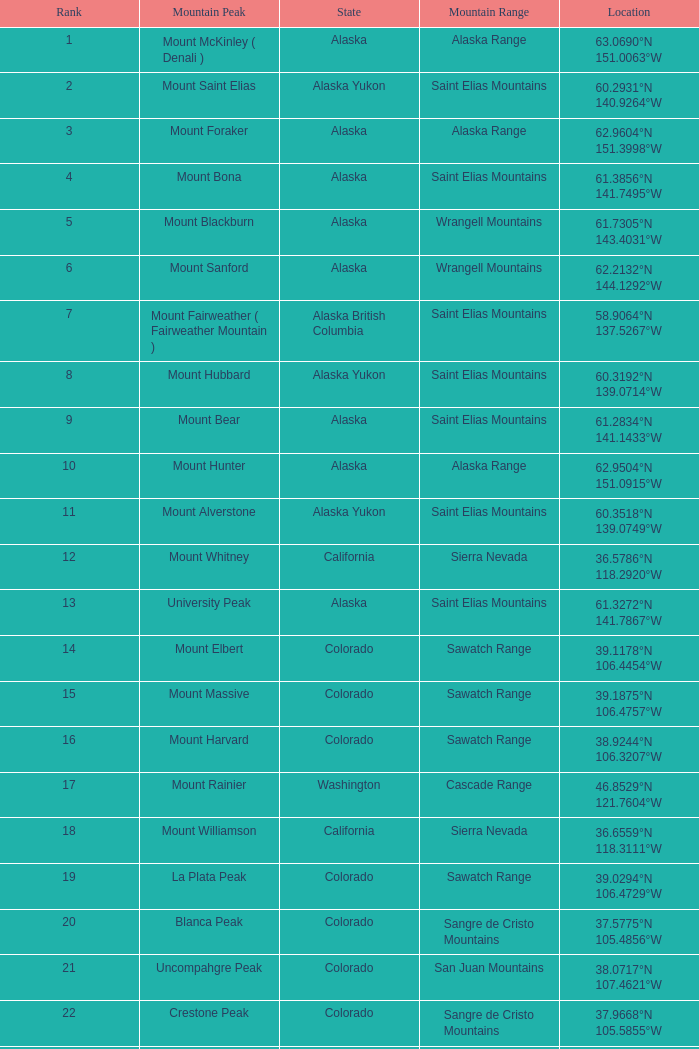4856°w? Blanca Peak. 